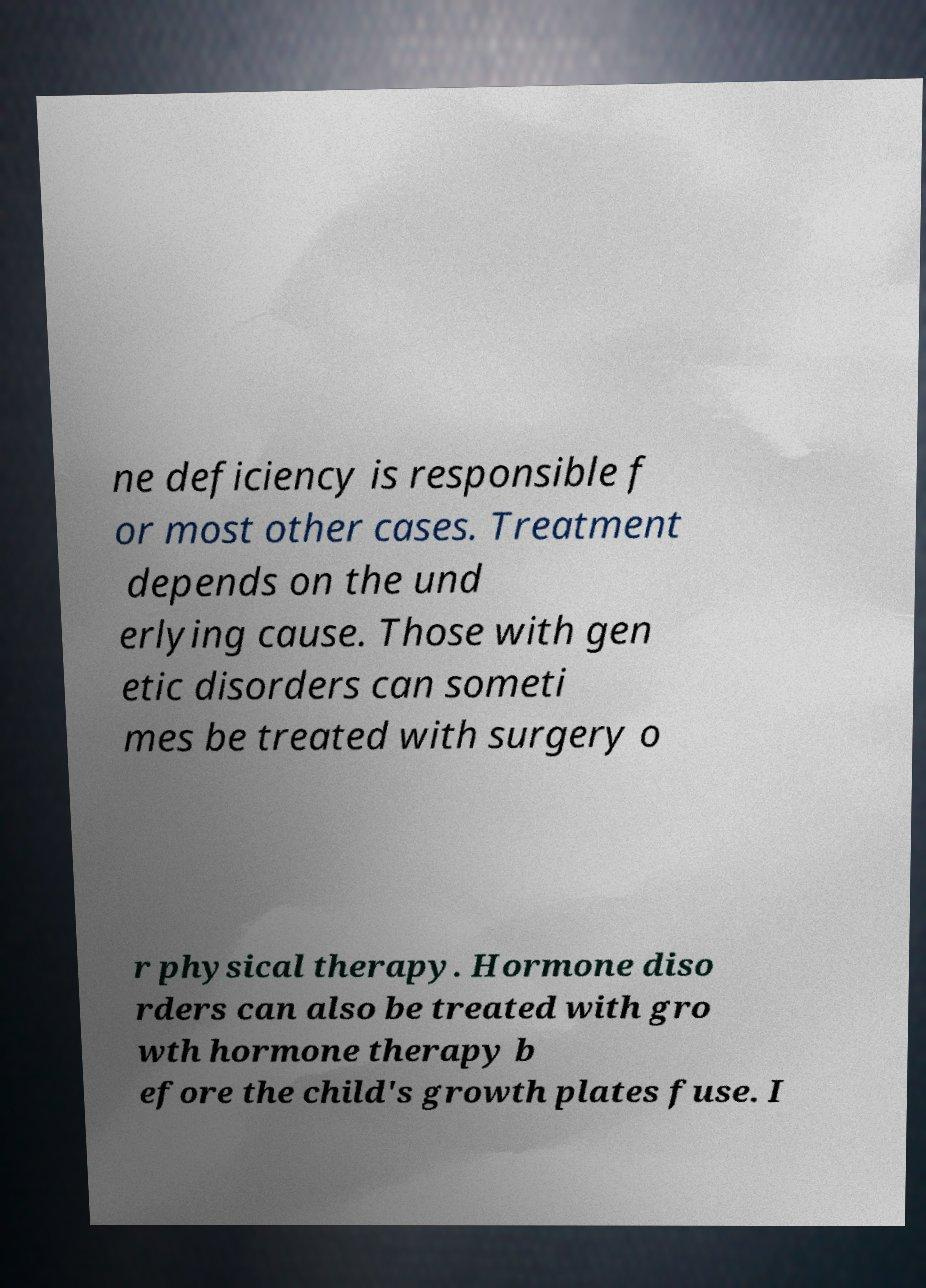What messages or text are displayed in this image? I need them in a readable, typed format. ne deficiency is responsible f or most other cases. Treatment depends on the und erlying cause. Those with gen etic disorders can someti mes be treated with surgery o r physical therapy. Hormone diso rders can also be treated with gro wth hormone therapy b efore the child's growth plates fuse. I 